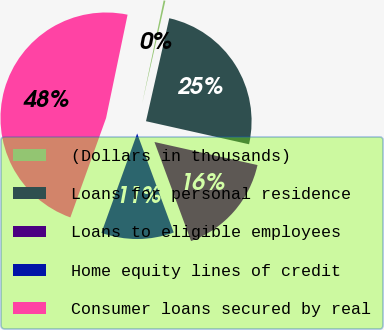Convert chart to OTSL. <chart><loc_0><loc_0><loc_500><loc_500><pie_chart><fcel>(Dollars in thousands)<fcel>Loans for personal residence<fcel>Loans to eligible employees<fcel>Home equity lines of credit<fcel>Consumer loans secured by real<nl><fcel>0.27%<fcel>24.97%<fcel>15.87%<fcel>11.12%<fcel>47.78%<nl></chart> 